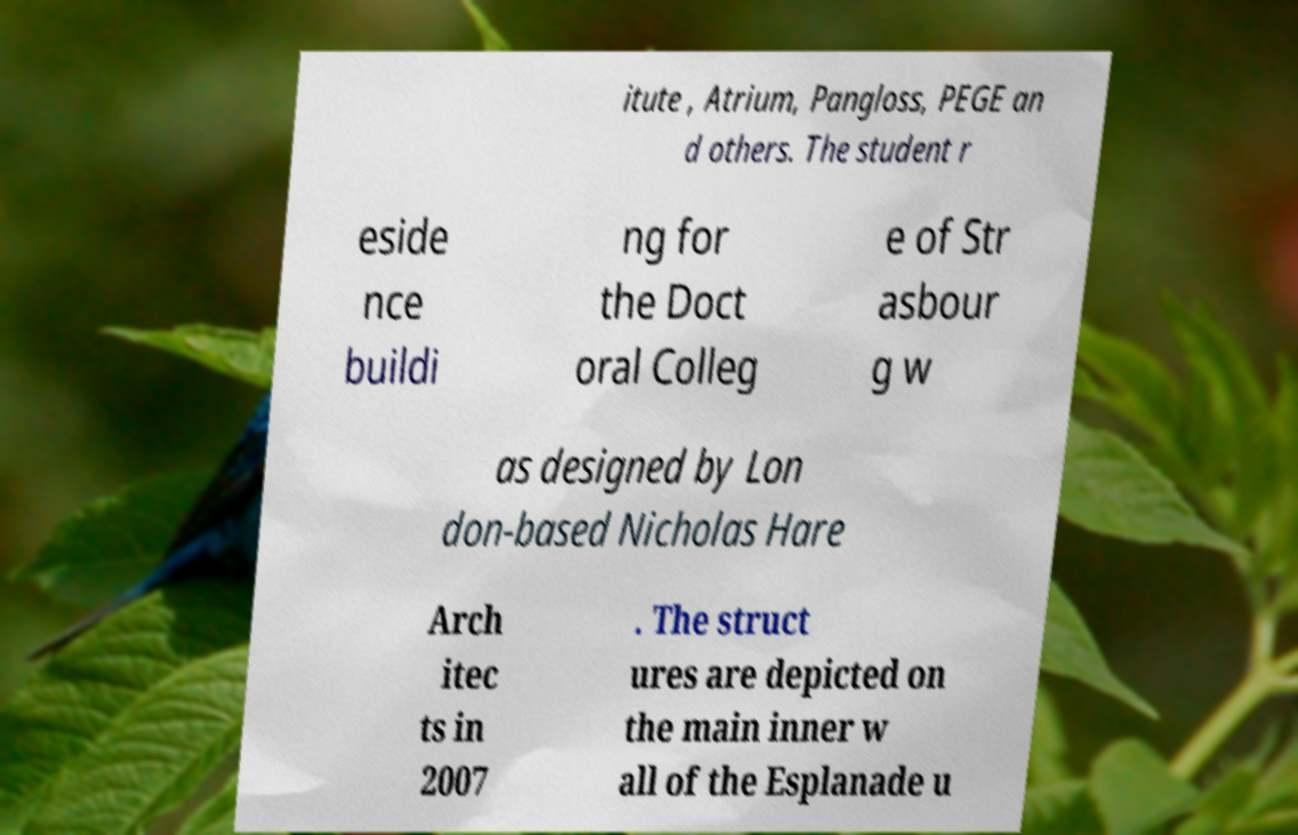Can you accurately transcribe the text from the provided image for me? itute , Atrium, Pangloss, PEGE an d others. The student r eside nce buildi ng for the Doct oral Colleg e of Str asbour g w as designed by Lon don-based Nicholas Hare Arch itec ts in 2007 . The struct ures are depicted on the main inner w all of the Esplanade u 